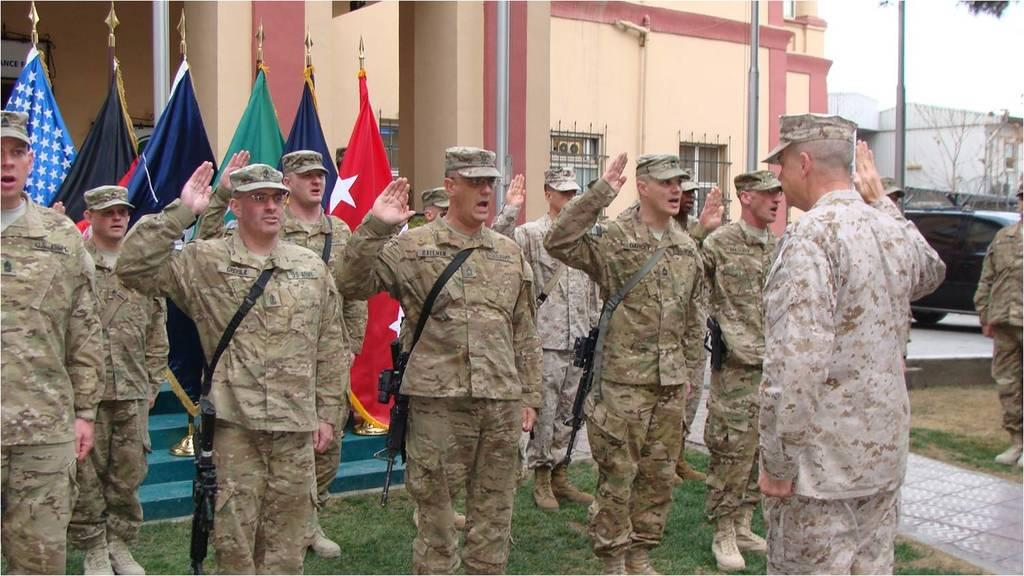What is the main subject of the image? The main subject of the image is a group of men standing on the grass. What else can be seen on the ground in the image? There is a vehicle on the ground. What are the flags in the image associated with? The flags in the image are associated with the group of men or the event they might be attending. What type of structures can be seen in the image? There are buildings in the image. What are the poles in the image used for? The poles in the image are likely used for supporting flags or other objects. What type of natural elements can be seen in the image? There are trees in the image. What is the unspecified objects in the image? The unspecified objects in the image could be additional vehicles, equipment, or other items related to the group of men or the event. What is visible in the background of the image? The sky is visible in the background of the image. What type of territory does the bear occupy in the image? There is no bear present in the image, so it is not possible to determine the type of territory it might occupy. 